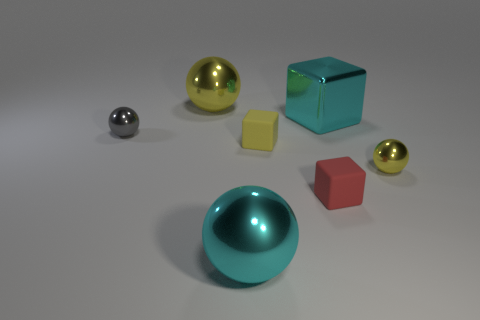Is the number of gray objects greater than the number of tiny red cylinders?
Provide a short and direct response. Yes. How many big cyan blocks are there?
Make the answer very short. 1. There is a cyan metallic object that is right of the sphere that is in front of the red block that is right of the big cyan shiny sphere; what is its shape?
Keep it short and to the point. Cube. Is the number of big yellow objects right of the yellow matte block less than the number of large blocks that are to the left of the gray metallic object?
Your response must be concise. No. There is a metallic object that is on the left side of the large yellow ball; does it have the same shape as the tiny metal object that is to the right of the large yellow metal sphere?
Give a very brief answer. Yes. What is the shape of the small object that is in front of the yellow shiny ball that is right of the small red rubber object?
Ensure brevity in your answer.  Cube. There is a shiny sphere that is the same color as the large metal block; what size is it?
Your response must be concise. Large. Are there any small yellow things made of the same material as the red thing?
Your answer should be compact. Yes. What material is the block behind the yellow block?
Offer a very short reply. Metal. What material is the large yellow object?
Make the answer very short. Metal. 